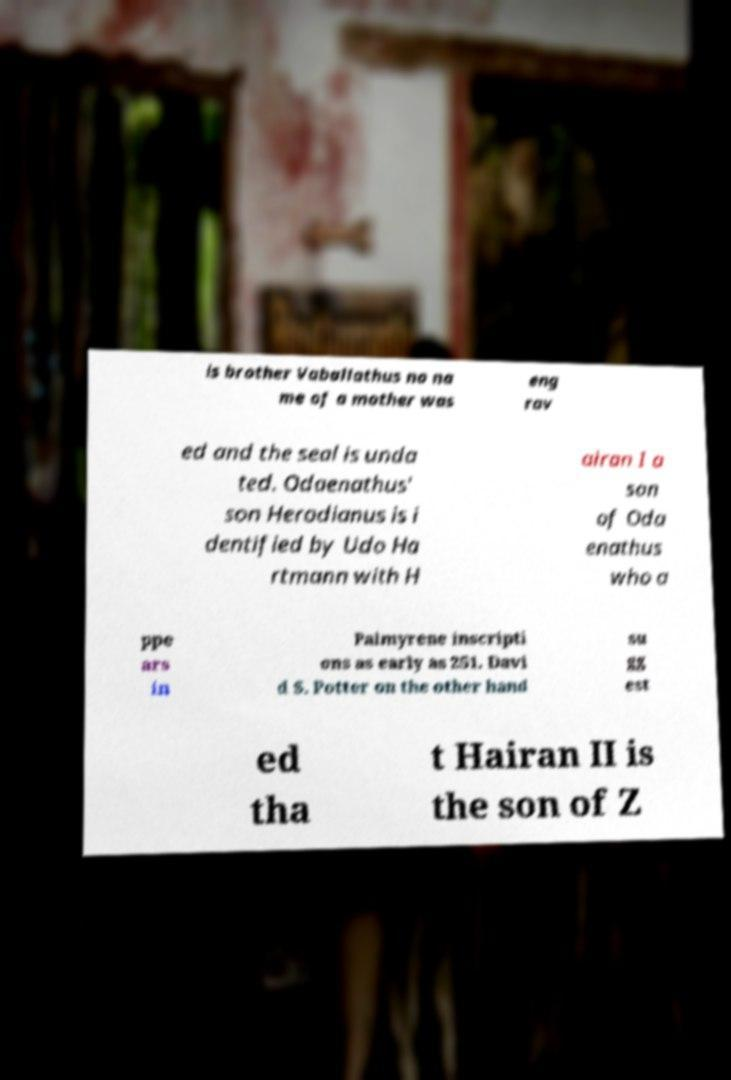Could you assist in decoding the text presented in this image and type it out clearly? is brother Vaballathus no na me of a mother was eng rav ed and the seal is unda ted. Odaenathus' son Herodianus is i dentified by Udo Ha rtmann with H airan I a son of Oda enathus who a ppe ars in Palmyrene inscripti ons as early as 251. Davi d S. Potter on the other hand su gg est ed tha t Hairan II is the son of Z 